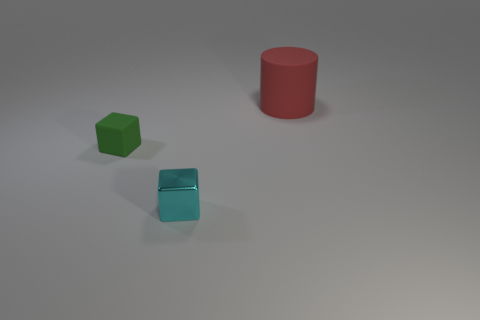Subtract 1 cubes. How many cubes are left? 1 Add 1 tiny green matte cubes. How many objects exist? 4 Add 2 cyan shiny objects. How many cyan shiny objects are left? 3 Add 3 big yellow things. How many big yellow things exist? 3 Subtract 0 green cylinders. How many objects are left? 3 Subtract all blocks. How many objects are left? 1 Subtract all blue blocks. Subtract all blue spheres. How many blocks are left? 2 Subtract all blue blocks. How many purple cylinders are left? 0 Subtract all small cubes. Subtract all matte cylinders. How many objects are left? 0 